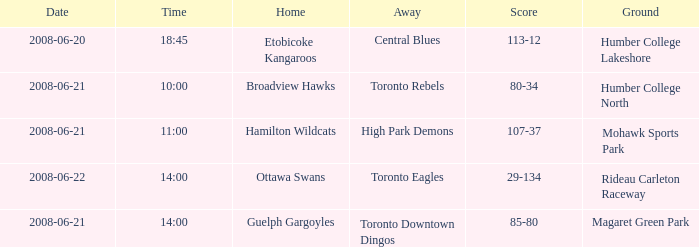What is the Away with a Ground that is humber college lakeshore? Central Blues. 